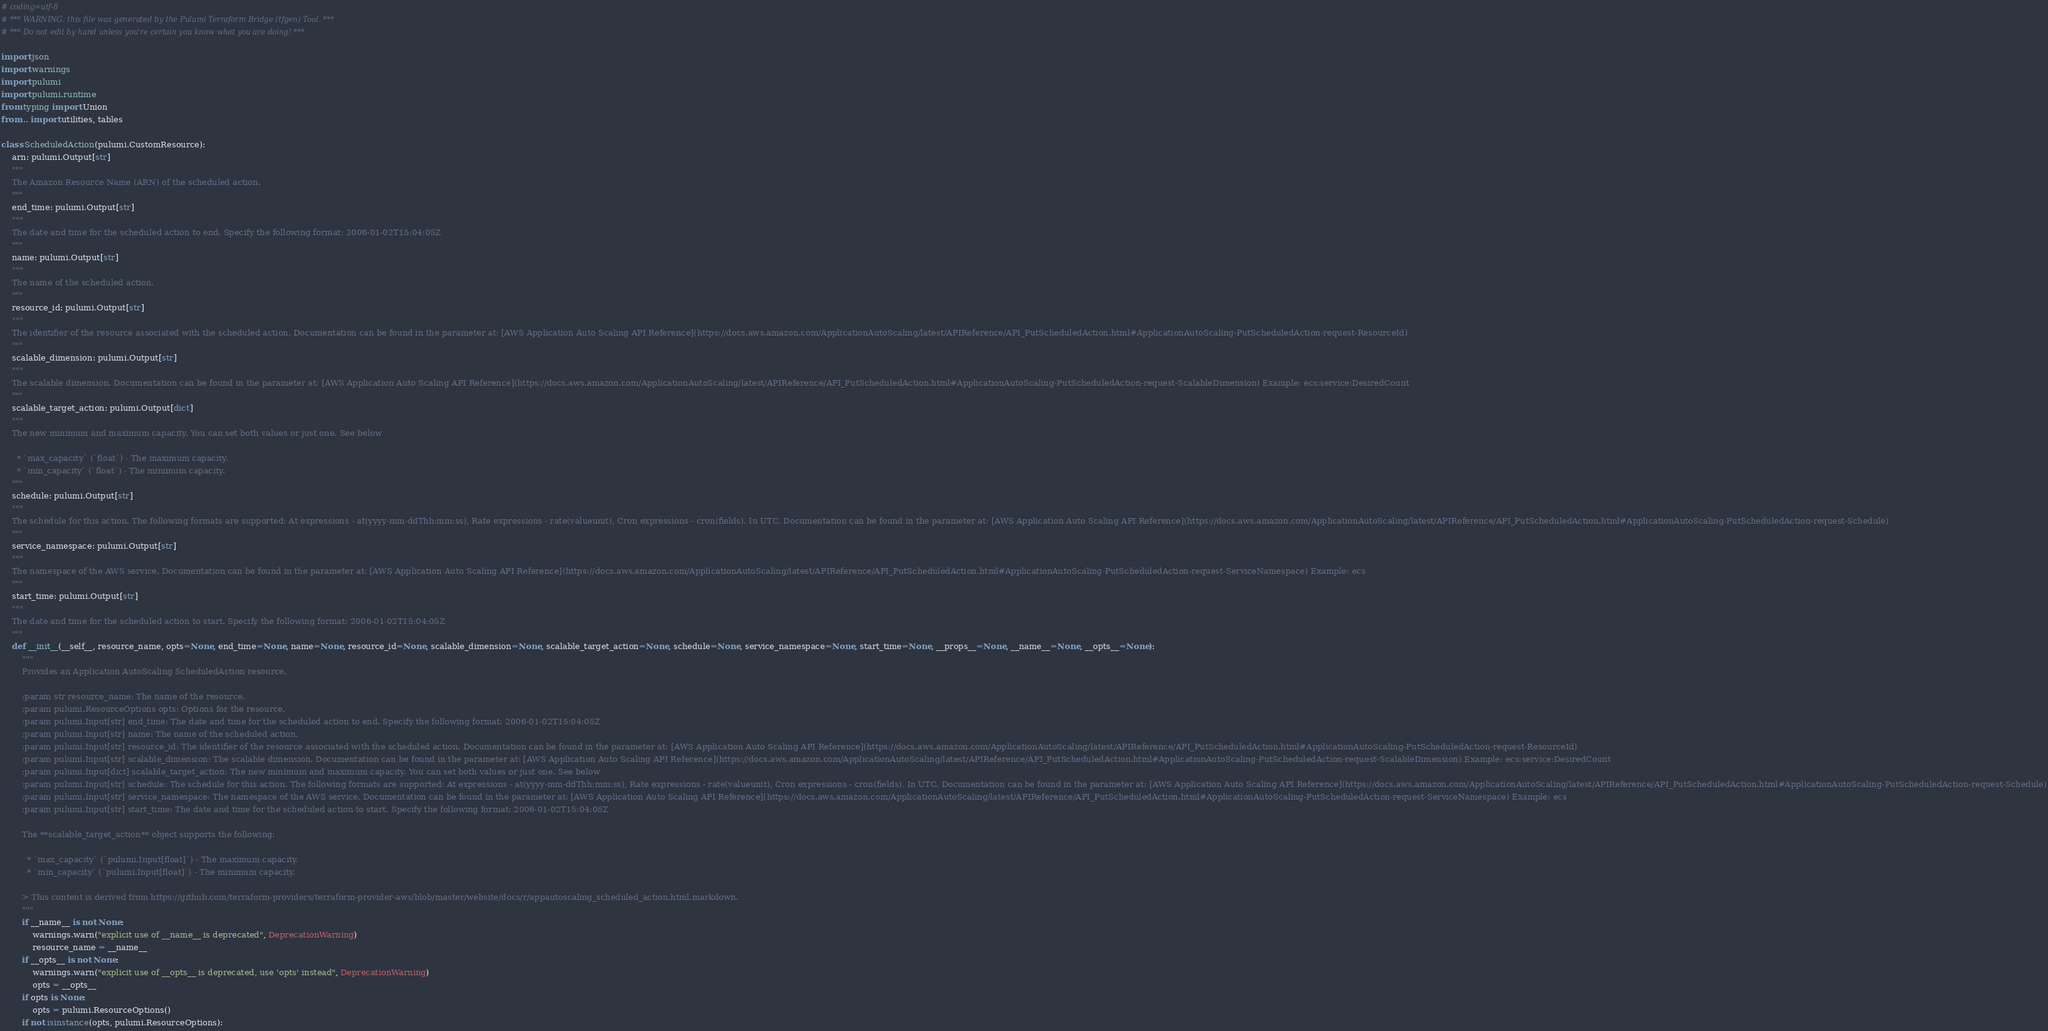Convert code to text. <code><loc_0><loc_0><loc_500><loc_500><_Python_># coding=utf-8
# *** WARNING: this file was generated by the Pulumi Terraform Bridge (tfgen) Tool. ***
# *** Do not edit by hand unless you're certain you know what you are doing! ***

import json
import warnings
import pulumi
import pulumi.runtime
from typing import Union
from .. import utilities, tables

class ScheduledAction(pulumi.CustomResource):
    arn: pulumi.Output[str]
    """
    The Amazon Resource Name (ARN) of the scheduled action.
    """
    end_time: pulumi.Output[str]
    """
    The date and time for the scheduled action to end. Specify the following format: 2006-01-02T15:04:05Z
    """
    name: pulumi.Output[str]
    """
    The name of the scheduled action.
    """
    resource_id: pulumi.Output[str]
    """
    The identifier of the resource associated with the scheduled action. Documentation can be found in the parameter at: [AWS Application Auto Scaling API Reference](https://docs.aws.amazon.com/ApplicationAutoScaling/latest/APIReference/API_PutScheduledAction.html#ApplicationAutoScaling-PutScheduledAction-request-ResourceId)
    """
    scalable_dimension: pulumi.Output[str]
    """
    The scalable dimension. Documentation can be found in the parameter at: [AWS Application Auto Scaling API Reference](https://docs.aws.amazon.com/ApplicationAutoScaling/latest/APIReference/API_PutScheduledAction.html#ApplicationAutoScaling-PutScheduledAction-request-ScalableDimension) Example: ecs:service:DesiredCount
    """
    scalable_target_action: pulumi.Output[dict]
    """
    The new minimum and maximum capacity. You can set both values or just one. See below
    
      * `max_capacity` (`float`) - The maximum capacity.
      * `min_capacity` (`float`) - The minimum capacity.
    """
    schedule: pulumi.Output[str]
    """
    The schedule for this action. The following formats are supported: At expressions - at(yyyy-mm-ddThh:mm:ss), Rate expressions - rate(valueunit), Cron expressions - cron(fields). In UTC. Documentation can be found in the parameter at: [AWS Application Auto Scaling API Reference](https://docs.aws.amazon.com/ApplicationAutoScaling/latest/APIReference/API_PutScheduledAction.html#ApplicationAutoScaling-PutScheduledAction-request-Schedule)
    """
    service_namespace: pulumi.Output[str]
    """
    The namespace of the AWS service. Documentation can be found in the parameter at: [AWS Application Auto Scaling API Reference](https://docs.aws.amazon.com/ApplicationAutoScaling/latest/APIReference/API_PutScheduledAction.html#ApplicationAutoScaling-PutScheduledAction-request-ServiceNamespace) Example: ecs
    """
    start_time: pulumi.Output[str]
    """
    The date and time for the scheduled action to start. Specify the following format: 2006-01-02T15:04:05Z
    """
    def __init__(__self__, resource_name, opts=None, end_time=None, name=None, resource_id=None, scalable_dimension=None, scalable_target_action=None, schedule=None, service_namespace=None, start_time=None, __props__=None, __name__=None, __opts__=None):
        """
        Provides an Application AutoScaling ScheduledAction resource.
        
        :param str resource_name: The name of the resource.
        :param pulumi.ResourceOptions opts: Options for the resource.
        :param pulumi.Input[str] end_time: The date and time for the scheduled action to end. Specify the following format: 2006-01-02T15:04:05Z
        :param pulumi.Input[str] name: The name of the scheduled action.
        :param pulumi.Input[str] resource_id: The identifier of the resource associated with the scheduled action. Documentation can be found in the parameter at: [AWS Application Auto Scaling API Reference](https://docs.aws.amazon.com/ApplicationAutoScaling/latest/APIReference/API_PutScheduledAction.html#ApplicationAutoScaling-PutScheduledAction-request-ResourceId)
        :param pulumi.Input[str] scalable_dimension: The scalable dimension. Documentation can be found in the parameter at: [AWS Application Auto Scaling API Reference](https://docs.aws.amazon.com/ApplicationAutoScaling/latest/APIReference/API_PutScheduledAction.html#ApplicationAutoScaling-PutScheduledAction-request-ScalableDimension) Example: ecs:service:DesiredCount
        :param pulumi.Input[dict] scalable_target_action: The new minimum and maximum capacity. You can set both values or just one. See below
        :param pulumi.Input[str] schedule: The schedule for this action. The following formats are supported: At expressions - at(yyyy-mm-ddThh:mm:ss), Rate expressions - rate(valueunit), Cron expressions - cron(fields). In UTC. Documentation can be found in the parameter at: [AWS Application Auto Scaling API Reference](https://docs.aws.amazon.com/ApplicationAutoScaling/latest/APIReference/API_PutScheduledAction.html#ApplicationAutoScaling-PutScheduledAction-request-Schedule)
        :param pulumi.Input[str] service_namespace: The namespace of the AWS service. Documentation can be found in the parameter at: [AWS Application Auto Scaling API Reference](https://docs.aws.amazon.com/ApplicationAutoScaling/latest/APIReference/API_PutScheduledAction.html#ApplicationAutoScaling-PutScheduledAction-request-ServiceNamespace) Example: ecs
        :param pulumi.Input[str] start_time: The date and time for the scheduled action to start. Specify the following format: 2006-01-02T15:04:05Z
        
        The **scalable_target_action** object supports the following:
        
          * `max_capacity` (`pulumi.Input[float]`) - The maximum capacity.
          * `min_capacity` (`pulumi.Input[float]`) - The minimum capacity.

        > This content is derived from https://github.com/terraform-providers/terraform-provider-aws/blob/master/website/docs/r/appautoscaling_scheduled_action.html.markdown.
        """
        if __name__ is not None:
            warnings.warn("explicit use of __name__ is deprecated", DeprecationWarning)
            resource_name = __name__
        if __opts__ is not None:
            warnings.warn("explicit use of __opts__ is deprecated, use 'opts' instead", DeprecationWarning)
            opts = __opts__
        if opts is None:
            opts = pulumi.ResourceOptions()
        if not isinstance(opts, pulumi.ResourceOptions):</code> 